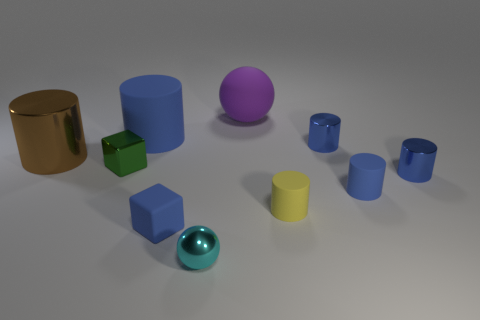Do the tiny matte thing on the left side of the tiny cyan object and the big rubber cylinder have the same color?
Give a very brief answer. Yes. There is a tiny thing that is on the left side of the small shiny ball and behind the rubber block; what is its material?
Your response must be concise. Metal. Is the number of matte things greater than the number of large purple matte balls?
Your response must be concise. Yes. There is a cube that is on the right side of the blue rubber cylinder that is behind the large cylinder that is left of the metallic cube; what color is it?
Offer a very short reply. Blue. Does the sphere behind the cyan sphere have the same material as the tiny blue block?
Offer a very short reply. Yes. Are there any blocks that have the same color as the big matte cylinder?
Your response must be concise. Yes. Are any big blue cylinders visible?
Provide a short and direct response. Yes. There is a blue matte cylinder to the left of the purple rubber thing; is it the same size as the purple ball?
Your response must be concise. Yes. Is the number of purple spheres less than the number of yellow metal cylinders?
Offer a terse response. No. What shape is the tiny object to the right of the small blue rubber thing that is right of the big rubber thing on the right side of the big rubber cylinder?
Provide a succinct answer. Cylinder. 